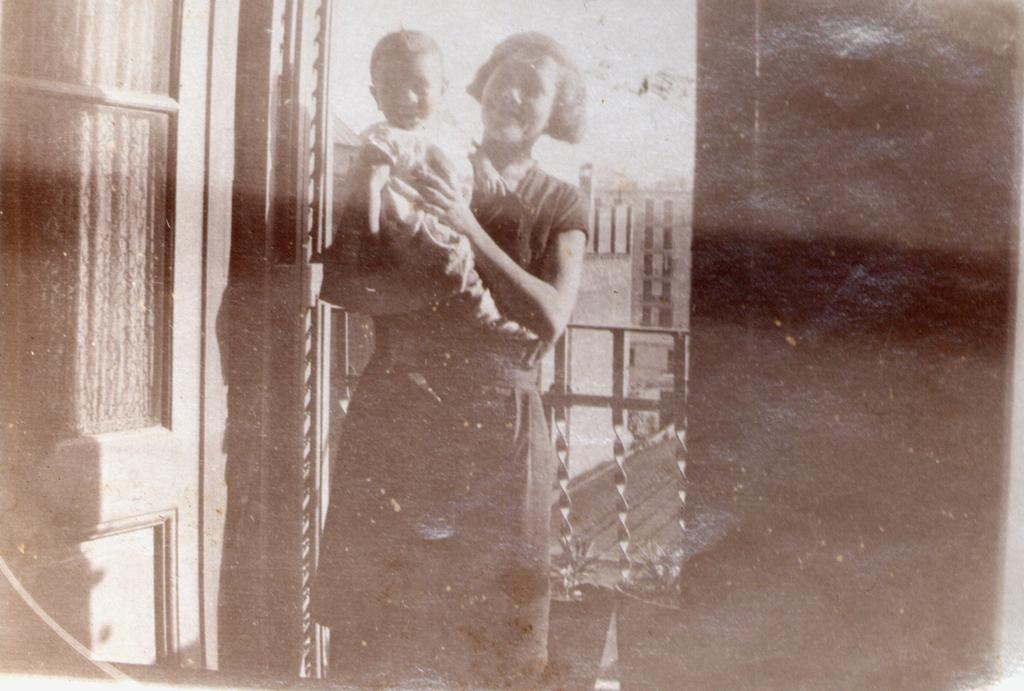Who is present in the image? There is a woman and a child in the image. What type of plants can be seen in the image? There are house plants in the image. What architectural features are visible in the image? There is a door and a wall in the image. What else can be seen in the image besides the people and plants? There are some objects in the image. What type of collar can be seen on the cart in the image? There is no cart or collar present in the image. 